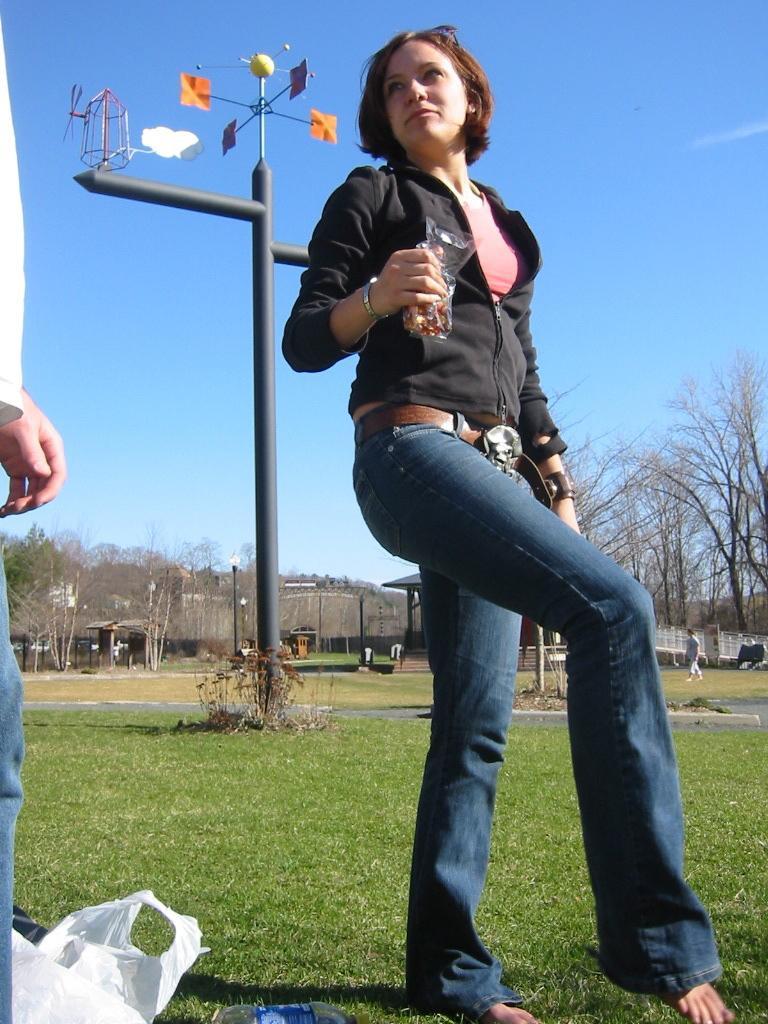Describe this image in one or two sentences. There is a woman holding a cover and we can see covers and bottle on the grass. On the left side of the image we can see a person. We can see weather forecasting device and plants. In the background we can see trees, shed, person, poles, board and sky. 